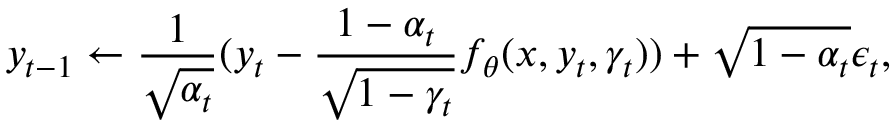Convert formula to latex. <formula><loc_0><loc_0><loc_500><loc_500>y _ { t - 1 } \leftarrow \frac { 1 } { \sqrt { \alpha _ { t } } } ( y _ { t } - \frac { 1 - \alpha _ { t } } { \sqrt { 1 - \gamma _ { t } } } f _ { \theta } ( x , y _ { t } , \gamma _ { t } ) ) + \sqrt { 1 - \alpha _ { t } } \epsilon _ { t } ,</formula> 